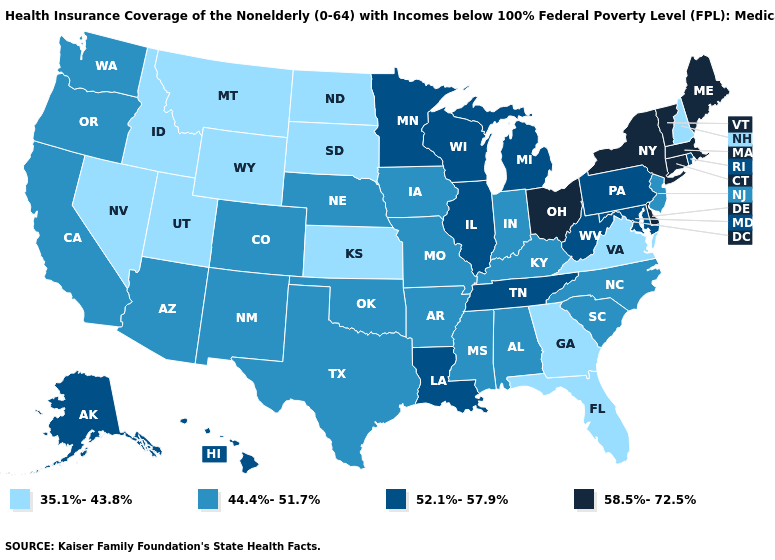Name the states that have a value in the range 35.1%-43.8%?
Short answer required. Florida, Georgia, Idaho, Kansas, Montana, Nevada, New Hampshire, North Dakota, South Dakota, Utah, Virginia, Wyoming. Which states have the highest value in the USA?
Give a very brief answer. Connecticut, Delaware, Maine, Massachusetts, New York, Ohio, Vermont. What is the highest value in the West ?
Short answer required. 52.1%-57.9%. What is the value of Kansas?
Write a very short answer. 35.1%-43.8%. Is the legend a continuous bar?
Short answer required. No. Name the states that have a value in the range 58.5%-72.5%?
Keep it brief. Connecticut, Delaware, Maine, Massachusetts, New York, Ohio, Vermont. Does Missouri have a higher value than Maine?
Give a very brief answer. No. Which states have the lowest value in the USA?
Short answer required. Florida, Georgia, Idaho, Kansas, Montana, Nevada, New Hampshire, North Dakota, South Dakota, Utah, Virginia, Wyoming. Which states have the lowest value in the South?
Give a very brief answer. Florida, Georgia, Virginia. Does Wisconsin have the lowest value in the USA?
Concise answer only. No. Name the states that have a value in the range 58.5%-72.5%?
Answer briefly. Connecticut, Delaware, Maine, Massachusetts, New York, Ohio, Vermont. What is the value of California?
Answer briefly. 44.4%-51.7%. What is the value of Kentucky?
Write a very short answer. 44.4%-51.7%. Does the first symbol in the legend represent the smallest category?
Answer briefly. Yes. What is the value of Wyoming?
Quick response, please. 35.1%-43.8%. 